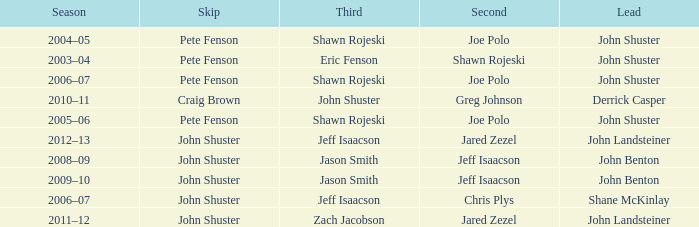Who was the lead with John Shuster as skip in the season of 2009–10? John Benton. 